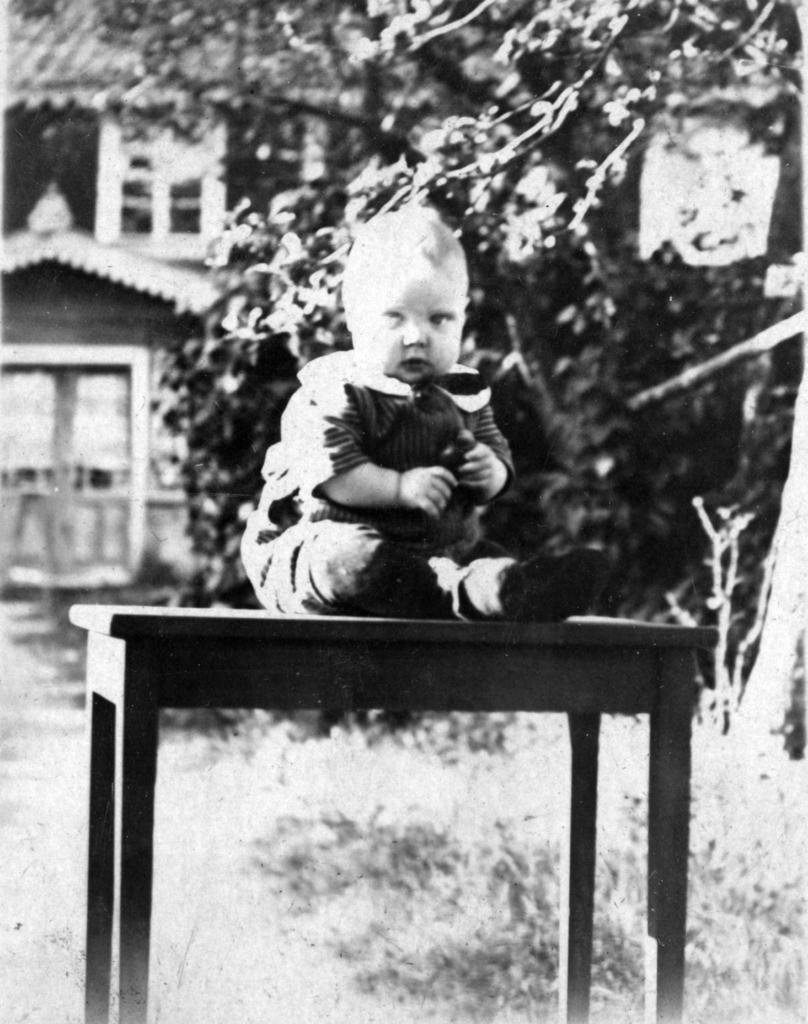What is the color scheme of the image? The image is black and white. Who or what is the main subject in the image? There is a child in the image. Where is the child sitting? The child is sitting on a table. What is the location of the table? The table is in a garden. What can be seen in the background of the image? There is a house and trees visible in the background. What type of vegetation is present below the table? Grass is present below the table. What type of coal is being used for the activity in the image? There is no coal or activity involving coal present in the image. Is the moon visible in the image? The moon is not visible in the image; it is a black and white image of a child sitting on a table in a garden. 